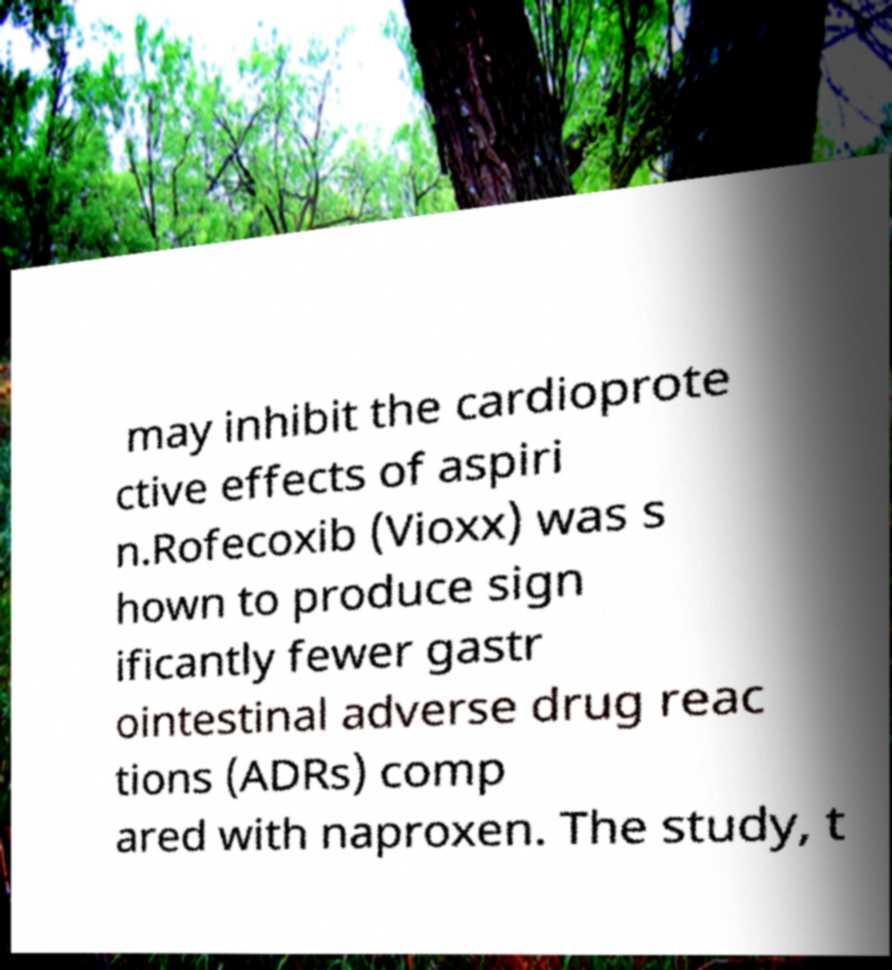Could you extract and type out the text from this image? may inhibit the cardioprote ctive effects of aspiri n.Rofecoxib (Vioxx) was s hown to produce sign ificantly fewer gastr ointestinal adverse drug reac tions (ADRs) comp ared with naproxen. The study, t 